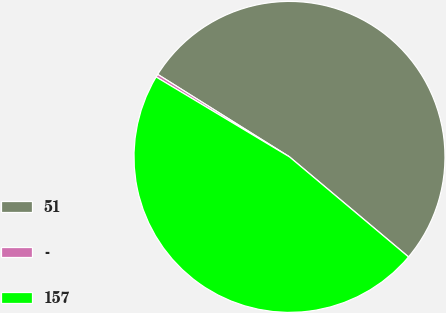Convert chart to OTSL. <chart><loc_0><loc_0><loc_500><loc_500><pie_chart><fcel>51<fcel>-<fcel>157<nl><fcel>52.22%<fcel>0.31%<fcel>47.47%<nl></chart> 